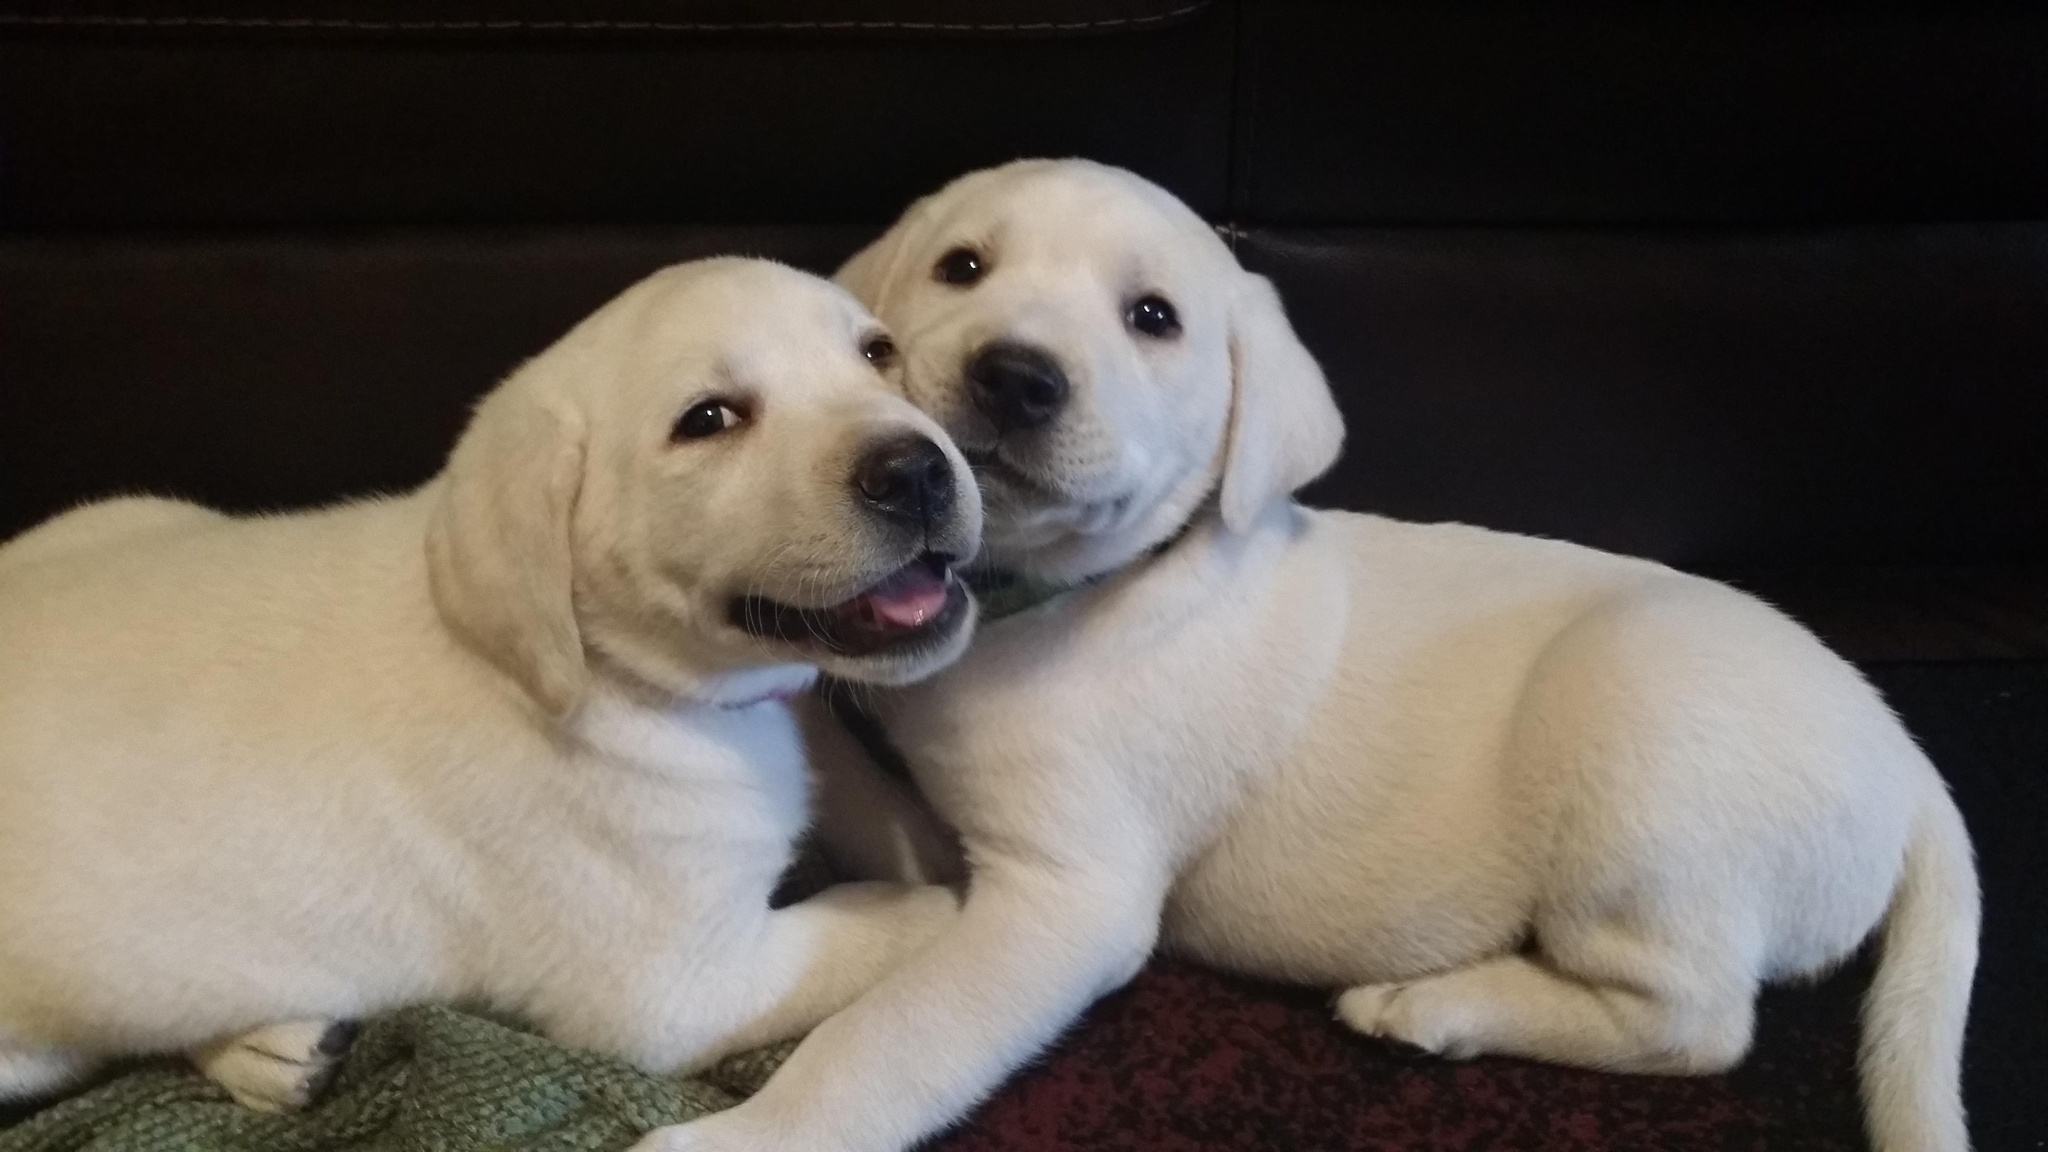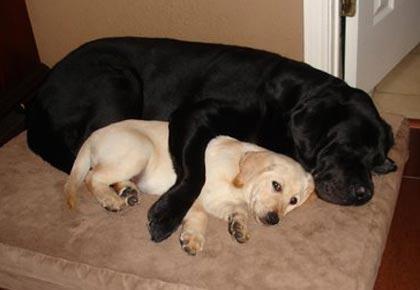The first image is the image on the left, the second image is the image on the right. Considering the images on both sides, is "The left image features one golden and one black colored Labrador while the right image contains two chocolate or black lab puppies." valid? Answer yes or no. No. The first image is the image on the left, the second image is the image on the right. Considering the images on both sides, is "An adult black dog and younger cream colored dog are together in an interior location, while in a second image, two puppies of the same color and breed snuggle together." valid? Answer yes or no. Yes. 